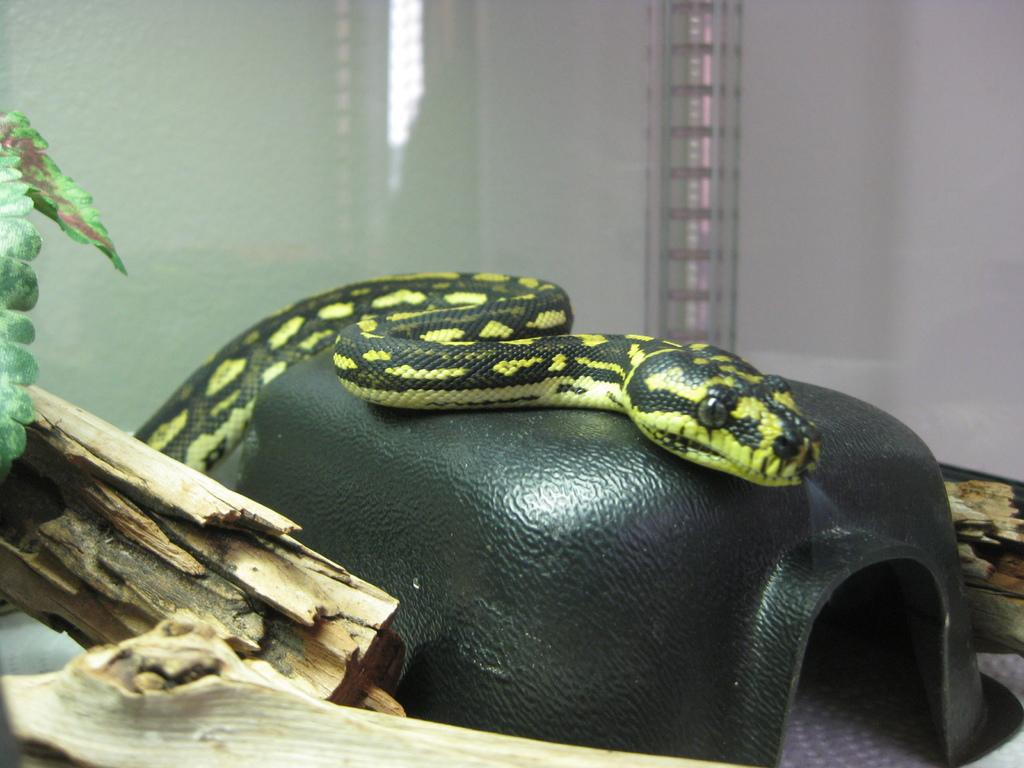What animal can be seen in the image? There is a snake on an object in the image. What type of sticks are visible in the image? There are wooden sticks in the image. What can be seen in the background of the image? There is a wall in the background of the image. What type of vegetation is present on the left side of the image? Leaves are present on the left side of the image. What type of caption is written on the wooden sticks in the image? There is no caption written on the wooden sticks in the image. How many pizzas are being served by the snake in the image? There are no pizzas present in the image. 